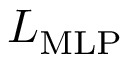Convert formula to latex. <formula><loc_0><loc_0><loc_500><loc_500>L _ { M L P }</formula> 